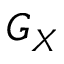Convert formula to latex. <formula><loc_0><loc_0><loc_500><loc_500>G _ { X }</formula> 